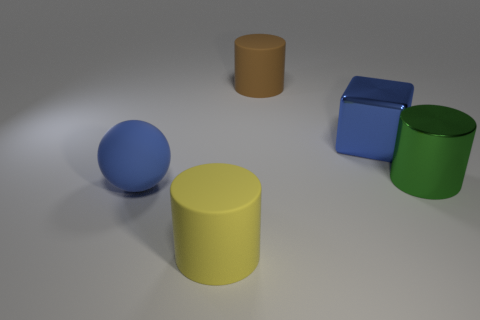Add 3 large matte cylinders. How many objects exist? 8 Subtract all spheres. How many objects are left? 4 Add 3 tiny gray shiny cylinders. How many tiny gray shiny cylinders exist? 3 Subtract 0 purple blocks. How many objects are left? 5 Subtract all small gray metallic balls. Subtract all big green objects. How many objects are left? 4 Add 4 blue rubber spheres. How many blue rubber spheres are left? 5 